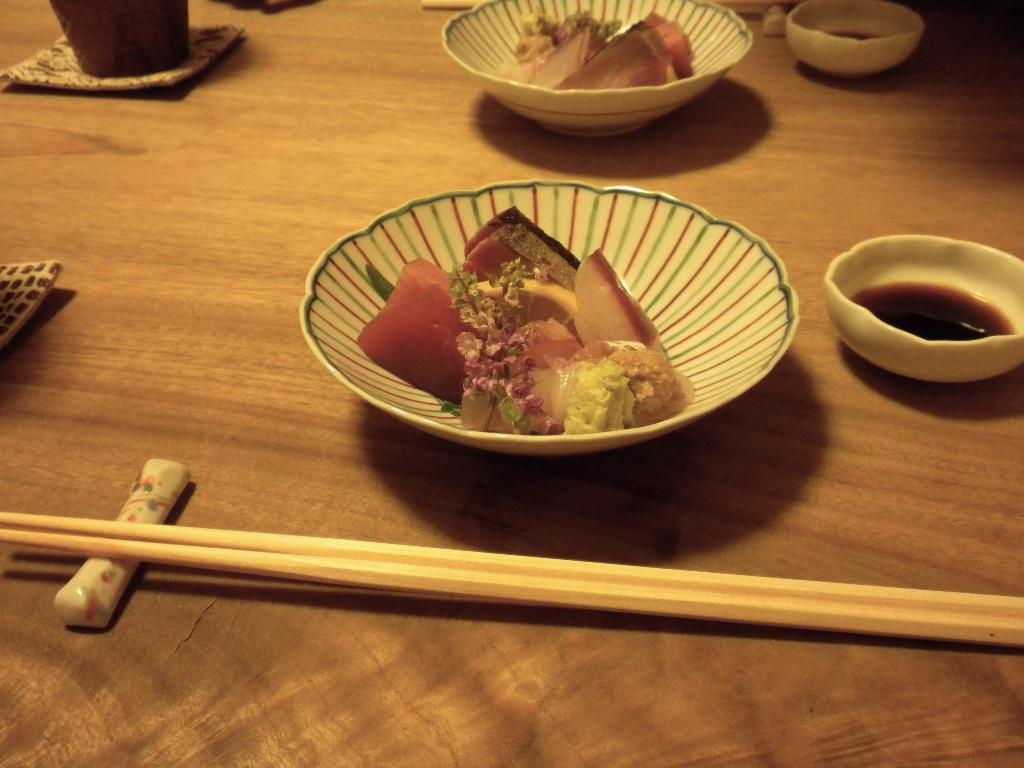What type of dishware can be seen in the image? There are bowls, a glass, and a plate in the image. What utensils are present in the image? There are chopsticks in the image. What is being served or eaten in the image? There are food items in the image. What type of wheel can be seen in the image? There is no wheel present in the image. Is there a van visible in the image? There is no van present in the image. 